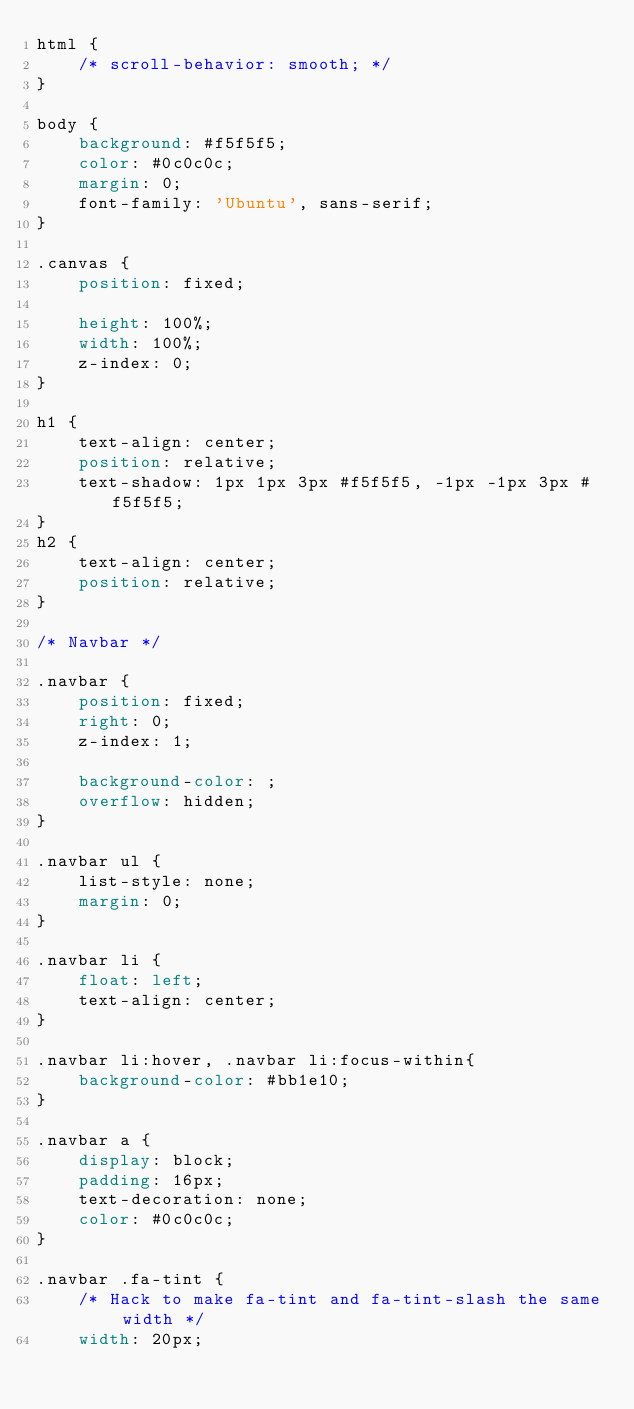Convert code to text. <code><loc_0><loc_0><loc_500><loc_500><_CSS_>html {
    /* scroll-behavior: smooth; */
}

body {
    background: #f5f5f5;
    color: #0c0c0c;
    margin: 0;
    font-family: 'Ubuntu', sans-serif;
}

.canvas {
    position: fixed;

    height: 100%;
    width: 100%;
    z-index: 0;
}

h1 {
    text-align: center;
    position: relative;
    text-shadow: 1px 1px 3px #f5f5f5, -1px -1px 3px #f5f5f5;
}
h2 {
    text-align: center;
    position: relative;
}

/* Navbar */

.navbar {
    position: fixed;
    right: 0;
    z-index: 1;

    background-color: ;
    overflow: hidden;
}

.navbar ul {
    list-style: none;
    margin: 0;
}

.navbar li {
    float: left;
    text-align: center;
}

.navbar li:hover, .navbar li:focus-within{
    background-color: #bb1e10;
}

.navbar a {
    display: block;
    padding: 16px;
    text-decoration: none;
    color: #0c0c0c;
}

.navbar .fa-tint {
    /* Hack to make fa-tint and fa-tint-slash the same width */
    width: 20px;</code> 